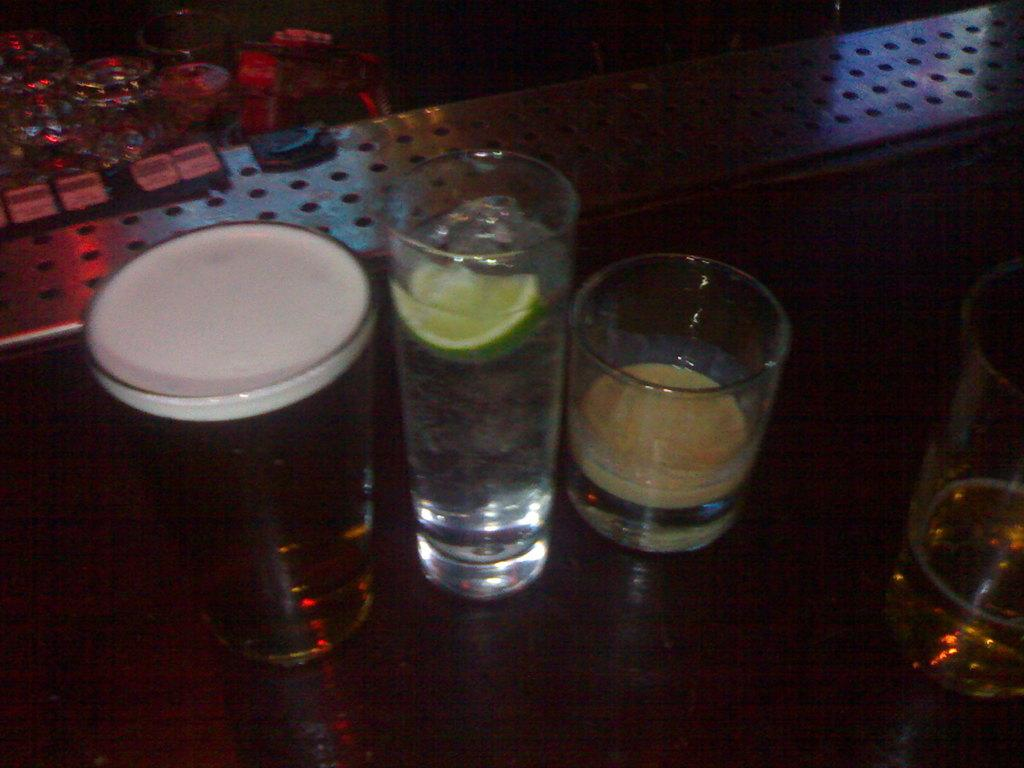What objects are present on the table in the image? There are four glasses with liquids on the table in the image. Can you describe the contents of the glasses? The glasses contain liquids, but the specific types of liquids are not mentioned in the facts. Are there any other glasses visible in the image? Yes, there are glasses visible in the background of the image. What type of railway can be seen in the image? There is no railway present in the image; it only features glasses with liquids on a table. 